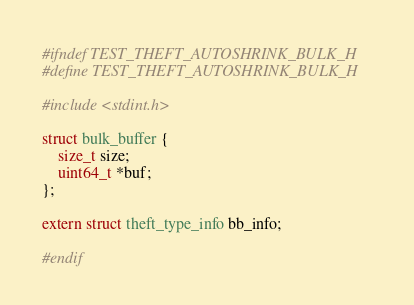Convert code to text. <code><loc_0><loc_0><loc_500><loc_500><_C_>#ifndef TEST_THEFT_AUTOSHRINK_BULK_H
#define TEST_THEFT_AUTOSHRINK_BULK_H

#include <stdint.h>

struct bulk_buffer {
    size_t size;
    uint64_t *buf;
};

extern struct theft_type_info bb_info;

#endif
</code> 